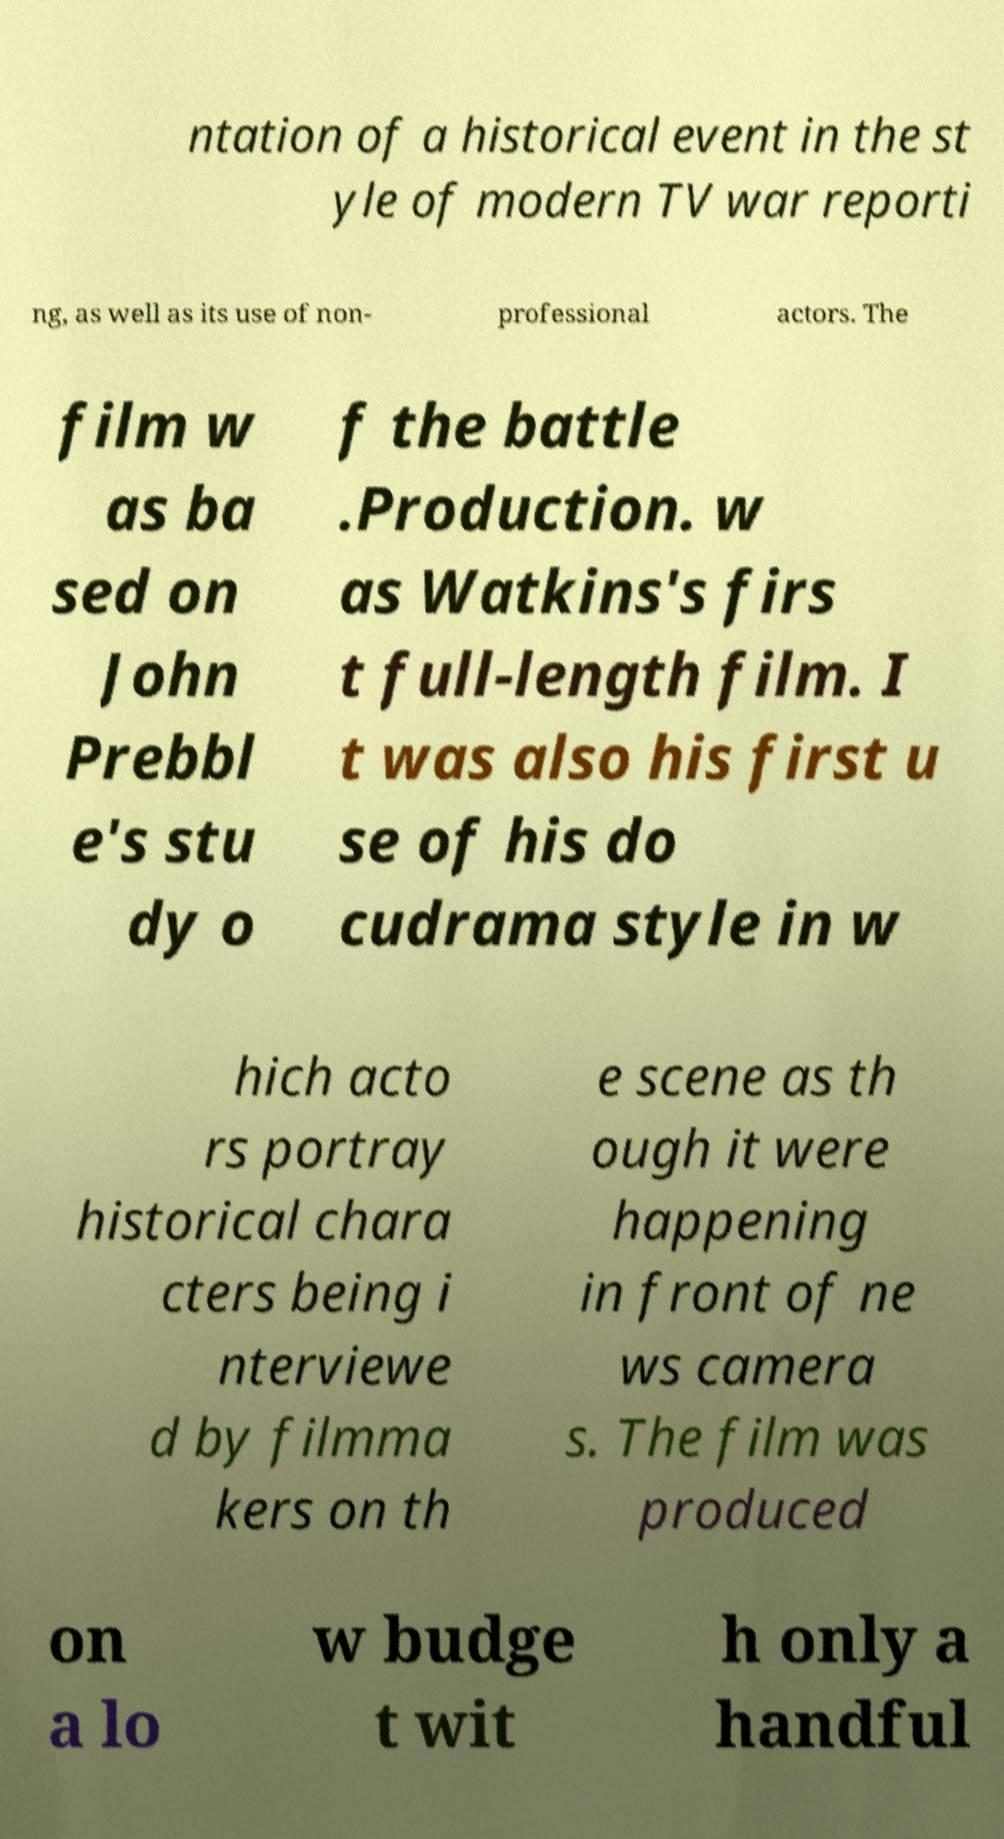Please read and relay the text visible in this image. What does it say? ntation of a historical event in the st yle of modern TV war reporti ng, as well as its use of non- professional actors. The film w as ba sed on John Prebbl e's stu dy o f the battle .Production. w as Watkins's firs t full-length film. I t was also his first u se of his do cudrama style in w hich acto rs portray historical chara cters being i nterviewe d by filmma kers on th e scene as th ough it were happening in front of ne ws camera s. The film was produced on a lo w budge t wit h only a handful 